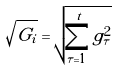<formula> <loc_0><loc_0><loc_500><loc_500>\sqrt { G _ { i } } = \sqrt { \sum _ { \tau = 1 } ^ { t } g _ { \tau } ^ { 2 } }</formula> 